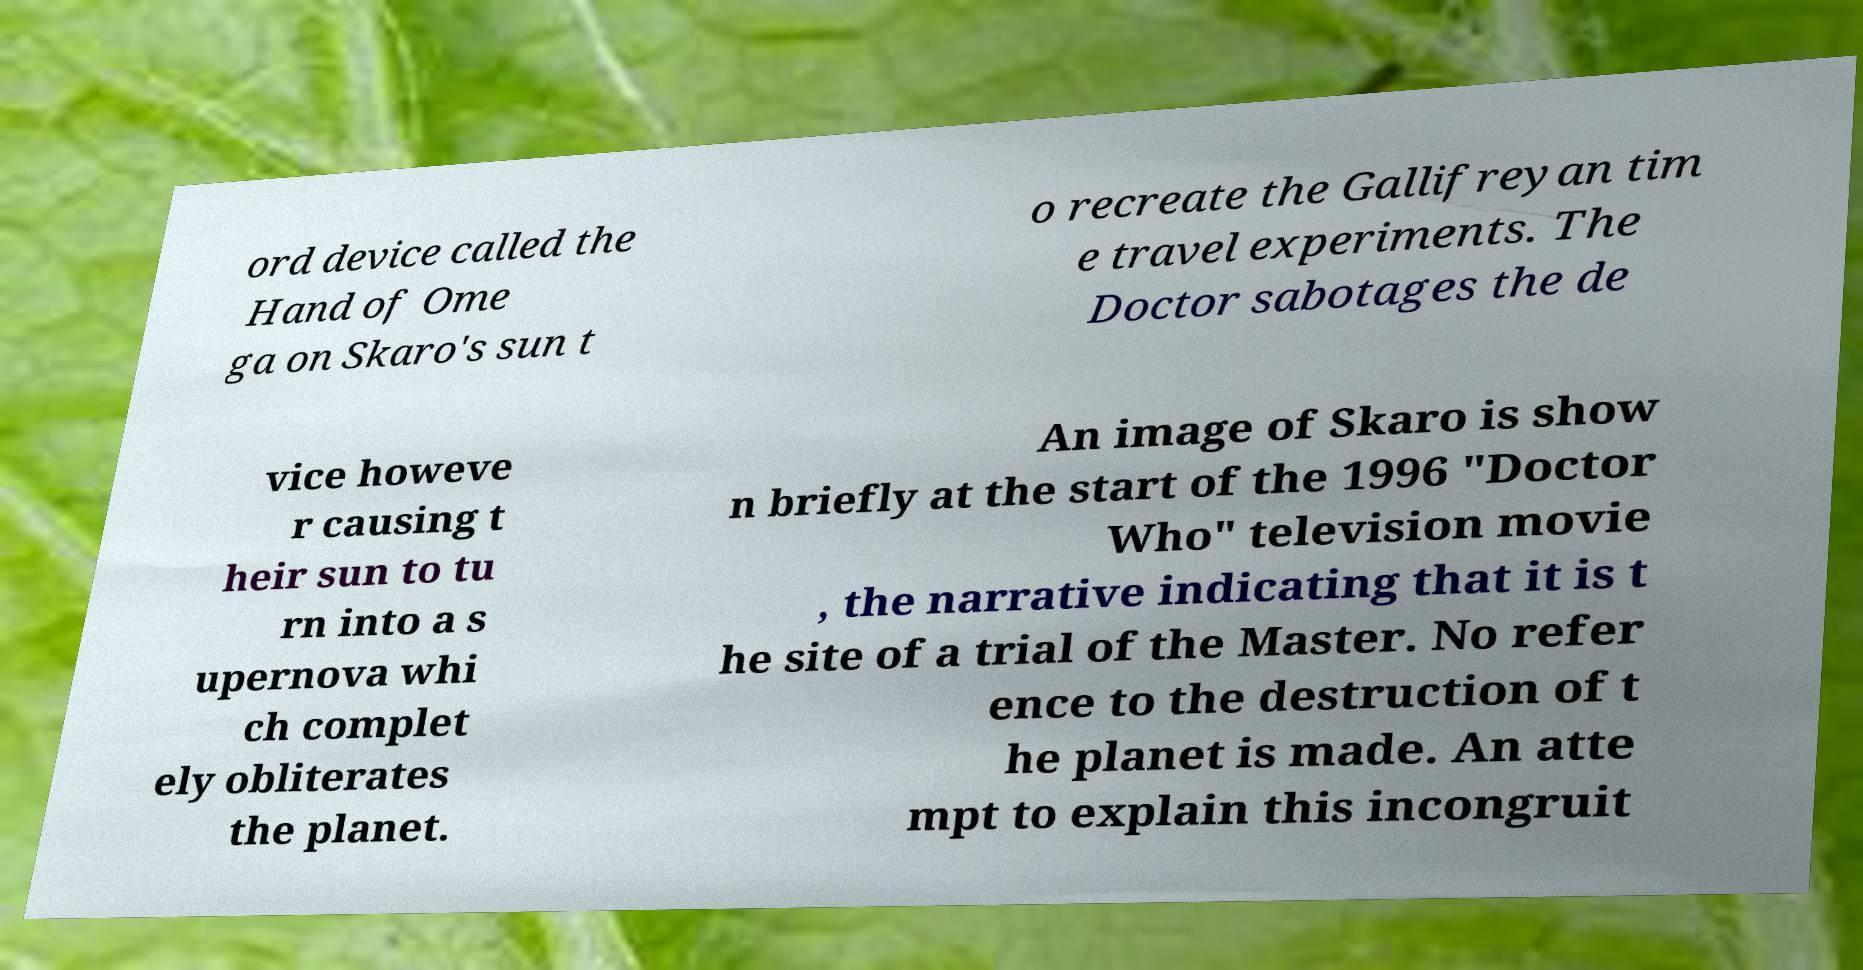Can you accurately transcribe the text from the provided image for me? ord device called the Hand of Ome ga on Skaro's sun t o recreate the Gallifreyan tim e travel experiments. The Doctor sabotages the de vice howeve r causing t heir sun to tu rn into a s upernova whi ch complet ely obliterates the planet. An image of Skaro is show n briefly at the start of the 1996 "Doctor Who" television movie , the narrative indicating that it is t he site of a trial of the Master. No refer ence to the destruction of t he planet is made. An atte mpt to explain this incongruit 